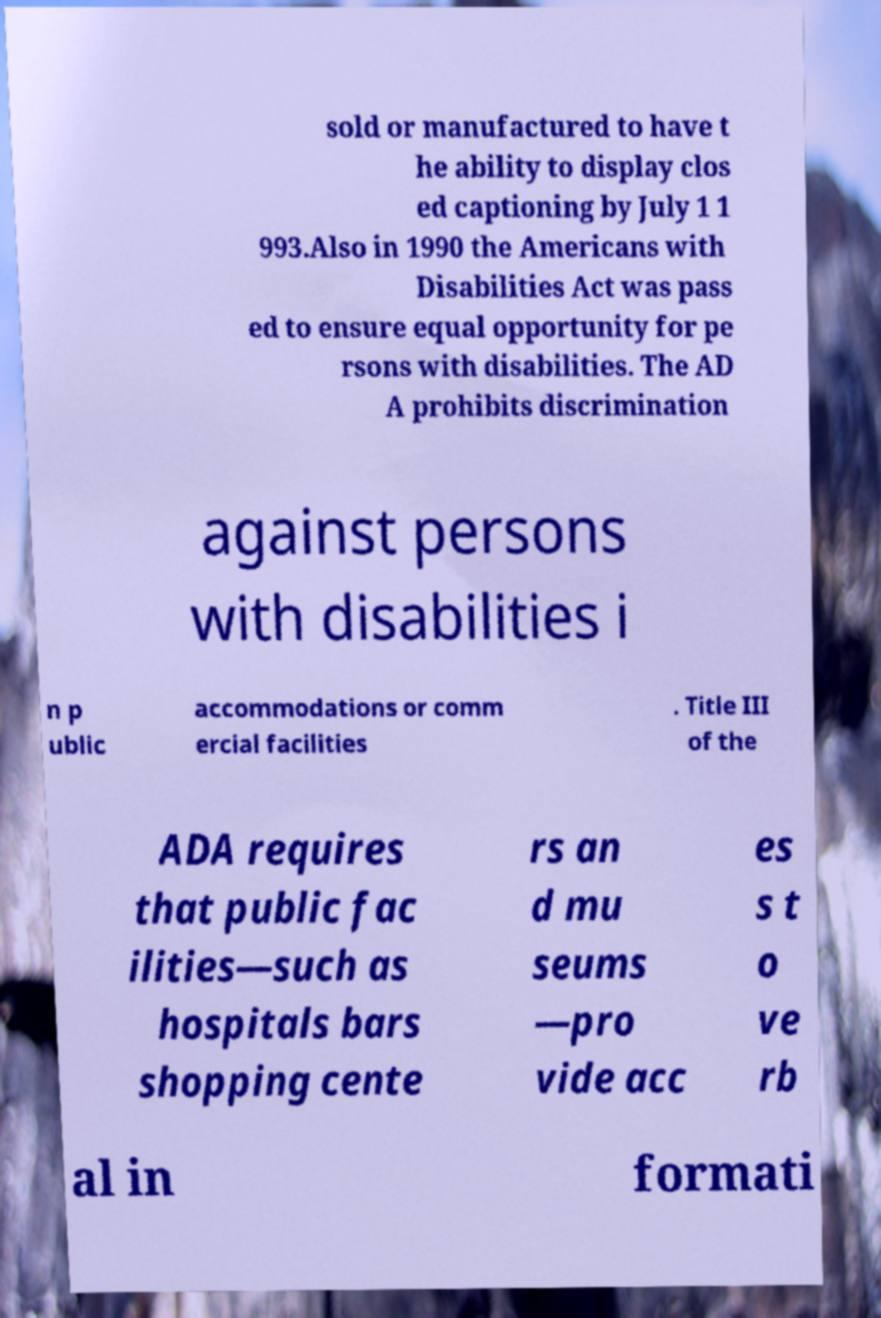There's text embedded in this image that I need extracted. Can you transcribe it verbatim? sold or manufactured to have t he ability to display clos ed captioning by July 1 1 993.Also in 1990 the Americans with Disabilities Act was pass ed to ensure equal opportunity for pe rsons with disabilities. The AD A prohibits discrimination against persons with disabilities i n p ublic accommodations or comm ercial facilities . Title III of the ADA requires that public fac ilities—such as hospitals bars shopping cente rs an d mu seums —pro vide acc es s t o ve rb al in formati 